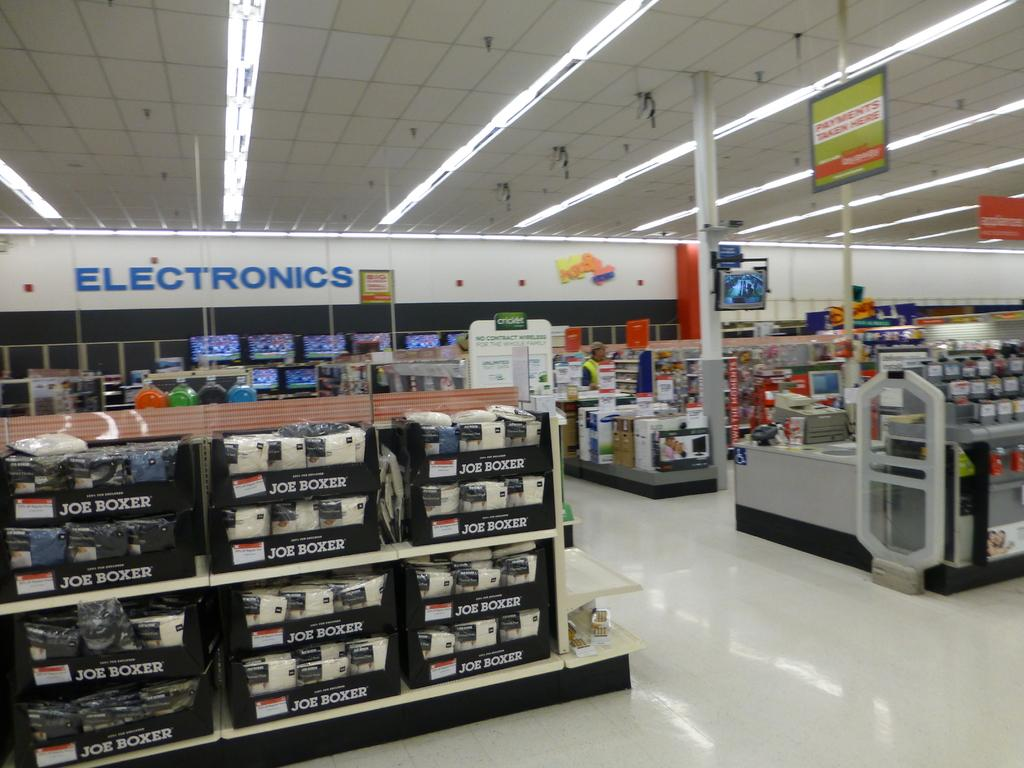<image>
Render a clear and concise summary of the photo. Electronics section of a store, and Joe Boxer socks and underwear that are displayed. 